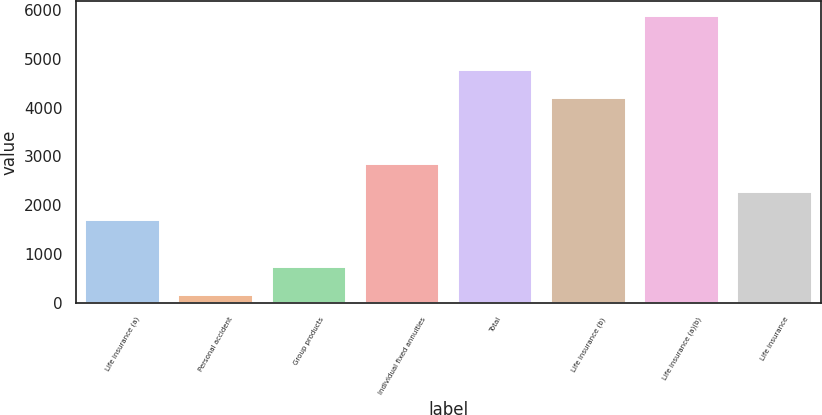Convert chart. <chart><loc_0><loc_0><loc_500><loc_500><bar_chart><fcel>Life insurance (a)<fcel>Personal accident<fcel>Group products<fcel>Individual fixed annuities<fcel>Total<fcel>Life insurance (b)<fcel>Life insurance (a)(b)<fcel>Life insurance<nl><fcel>1696<fcel>162<fcel>734.2<fcel>2840.4<fcel>4760.2<fcel>4188<fcel>5884<fcel>2268.2<nl></chart> 